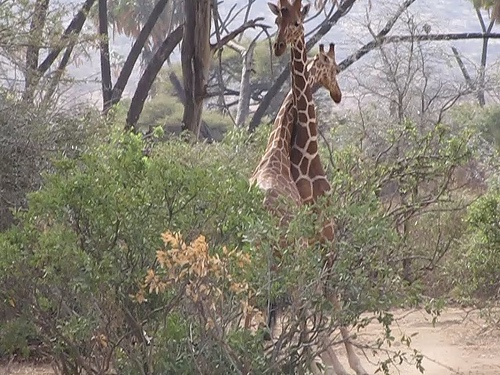Describe the objects in this image and their specific colors. I can see giraffe in darkgray, brown, black, and gray tones and giraffe in darkgray and gray tones in this image. 